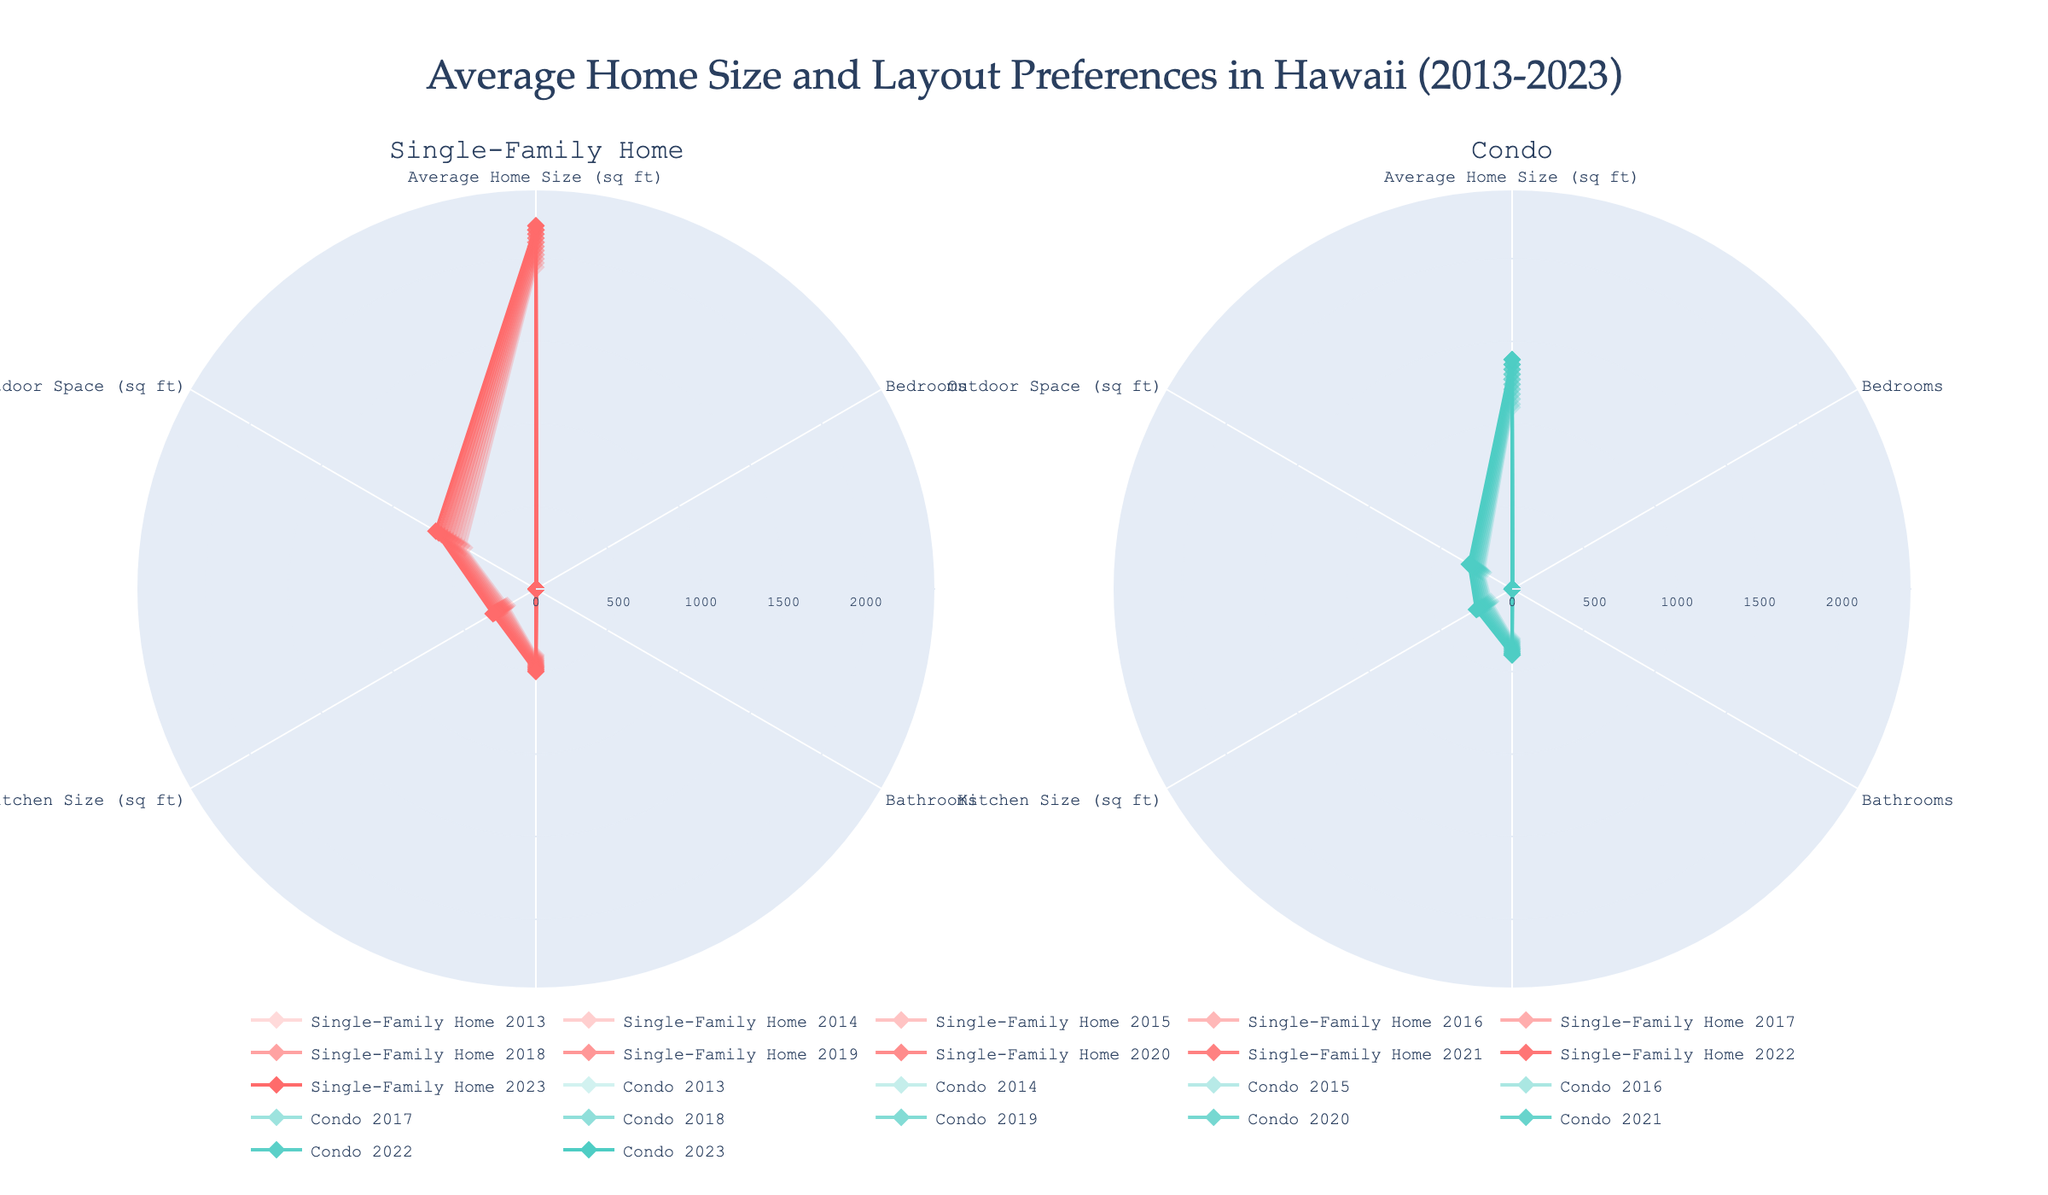What is the title of the figure? The title is displayed at the top center of the figure. It is prominently displayed and easy to read.
Answer: Average Home Size and Layout Preferences in Hawaii (2013-2023) How many subplots are in the figure? The figure has two distinct sections or subplots. Each section is labeled at the top of the subplot area.
Answer: 2 What are the types of homes compared in the figure? Each subplot title specifies the type of home it represents.
Answer: Single-Family Home and Condo In 2023, which type of home has a larger average home size? The radar chart prompts a direct visual comparison between the two subplots for the year 2023, focusing on the 'Average Home Size (sq ft)' axis.
Answer: Single-Family Home How has the kitchen size in condos changed from 2013 to 2023? Follow the 'Kitchen Size (sq ft)' axis in the Condo subplot, comparing the figures over the years.
Answer: Increased What is the average number of bedrooms for both home types combined in 2017? Both radar charts show that the 'Bedrooms' metric remains constant. A simple average calculation can confirm this.
Answer: 2.5 Compare the outdoor space in 2015 for both home types. Which has more? By looking at the 'Outdoor Space (sq ft)' axis for both subplots in the year 2015, we can compare the length of the respective lines.
Answer: Single-Family Home Between 2013 and 2023, which home type saw the greatest increase in outdoor space? Examine the 'Outdoor Space (sq ft)' axis for both subplots and calculate the difference between 2013 and 2023 for each home type.
Answer: Single-Family Home Do condos or single-family homes have more bathrooms? Both radar charts show the 'Bathrooms' feature, which remains the same for all years. Comparing the values directly answers this question.
Answer: Same (2) 